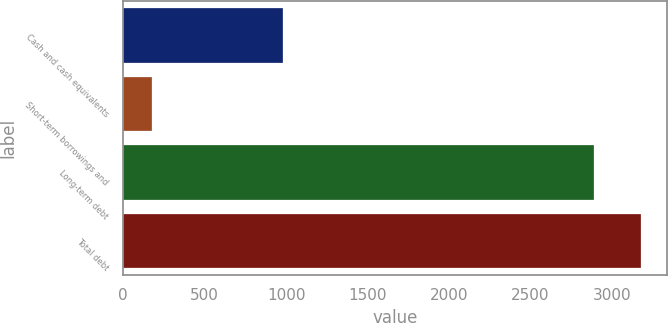Convert chart to OTSL. <chart><loc_0><loc_0><loc_500><loc_500><bar_chart><fcel>Cash and cash equivalents<fcel>Short-term borrowings and<fcel>Long-term debt<fcel>Total debt<nl><fcel>984<fcel>177<fcel>2887<fcel>3175.7<nl></chart> 